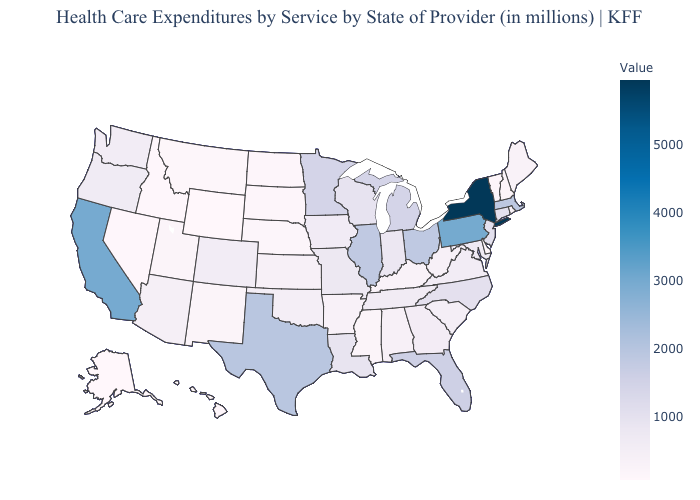Which states have the lowest value in the MidWest?
Write a very short answer. South Dakota. Does Idaho have the highest value in the USA?
Concise answer only. No. Which states hav the highest value in the West?
Be succinct. California. 